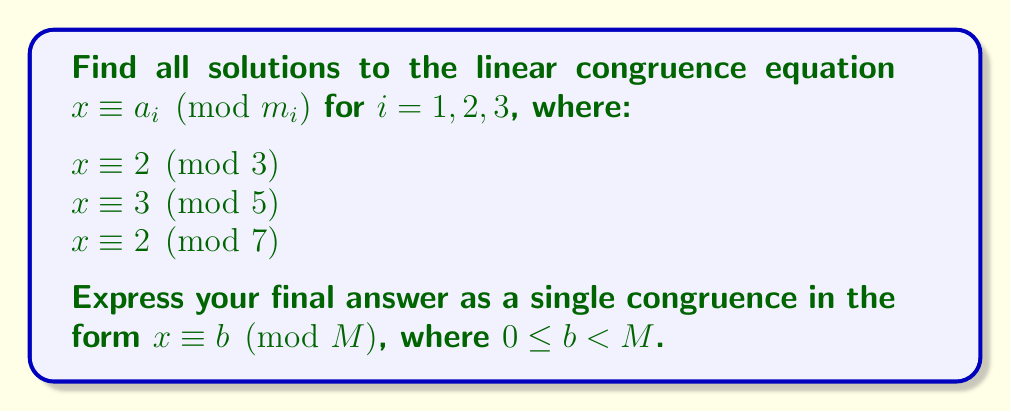Show me your answer to this math problem. To solve this system of linear congruences using the Chinese Remainder Theorem (CRT), we follow these steps:

1) First, calculate $M = m_1 \cdot m_2 \cdot m_3 = 3 \cdot 5 \cdot 7 = 105$.

2) For each congruence, calculate $M_i = M / m_i$:
   $M_1 = 105 / 3 = 35$
   $M_2 = 105 / 5 = 21$
   $M_3 = 105 / 7 = 15$

3) Find the modular multiplicative inverses of each $M_i$ modulo $m_i$:
   $35^{-1} \equiv 2 \pmod{3}$, as $35 \cdot 2 \equiv 1 \pmod{3}$
   $21^{-1} \equiv 1 \pmod{5}$, as $21 \cdot 1 \equiv 1 \pmod{5}$
   $15^{-1} \equiv 1 \pmod{7}$, as $15 \cdot 1 \equiv 1 \pmod{7}$

4) Calculate $x = \sum_{i=1}^{3} a_i \cdot M_i \cdot (M_i^{-1} \bmod m_i) \pmod{M}$:

   $x \equiv (2 \cdot 35 \cdot 2 + 3 \cdot 21 \cdot 1 + 2 \cdot 15 \cdot 1) \pmod{105}$
   $x \equiv (140 + 63 + 30) \pmod{105}$
   $x \equiv 233 \pmod{105}$
   $x \equiv 23 \pmod{105}$

Therefore, the solution to the system of congruences is $x \equiv 23 \pmod{105}$.
Answer: $x \equiv 23 \pmod{105}$ 